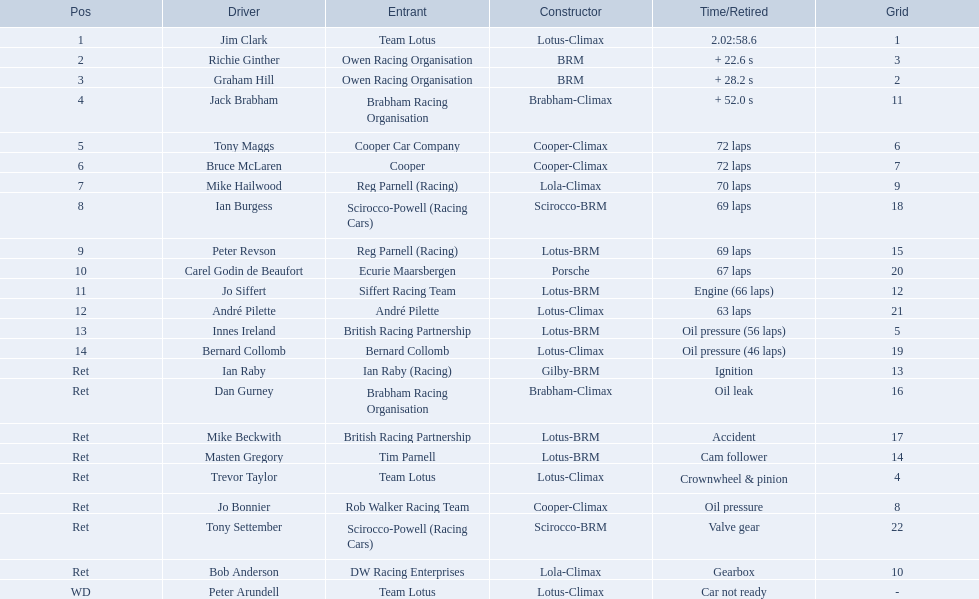Who were the racers in the 1963 international gold cup? Jim Clark, Richie Ginther, Graham Hill, Jack Brabham, Tony Maggs, Bruce McLaren, Mike Hailwood, Ian Burgess, Peter Revson, Carel Godin de Beaufort, Jo Siffert, André Pilette, Innes Ireland, Bernard Collomb, Ian Raby, Dan Gurney, Mike Beckwith, Masten Gregory, Trevor Taylor, Jo Bonnier, Tony Settember, Bob Anderson, Peter Arundell. In which position did tony maggs end up? 5. What was jo siffert's standing? 11. Who completed the race earlier? Tony Maggs. 